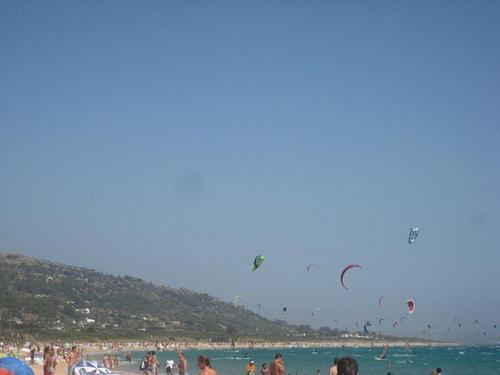How many clouds are in the sky?
Give a very brief answer. 0. 